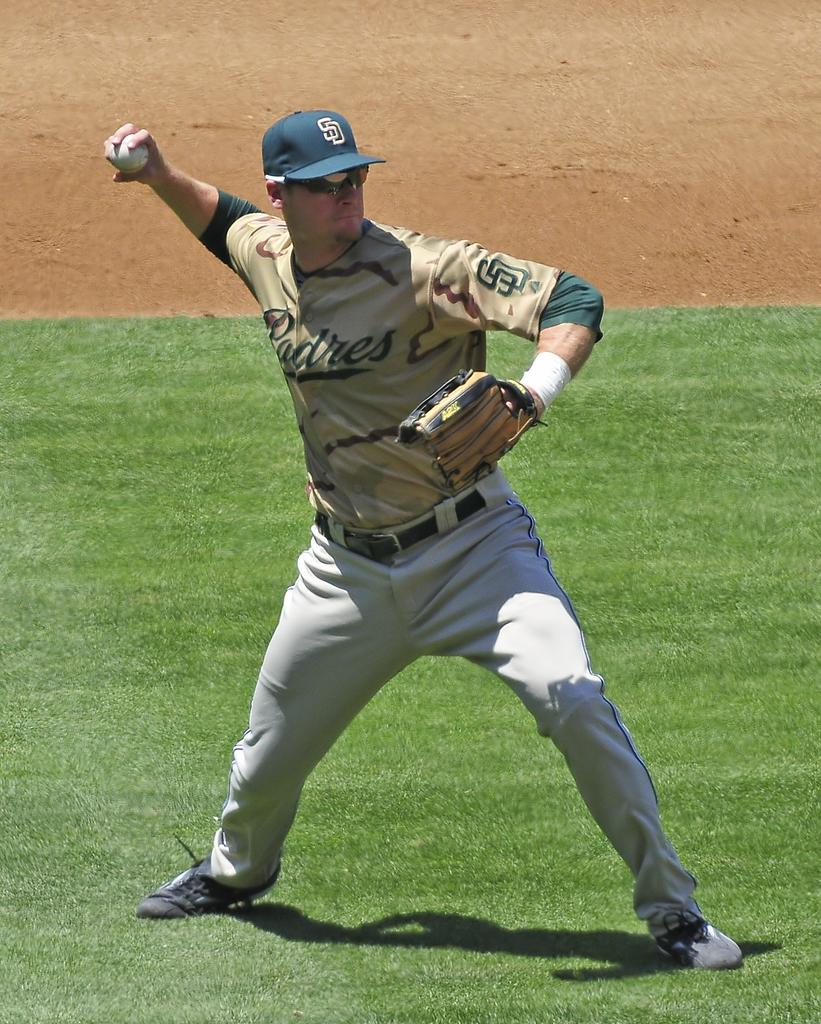<image>
Offer a succinct explanation of the picture presented. San Diego Padres pitcher that is getting ready to throw the baseball. 